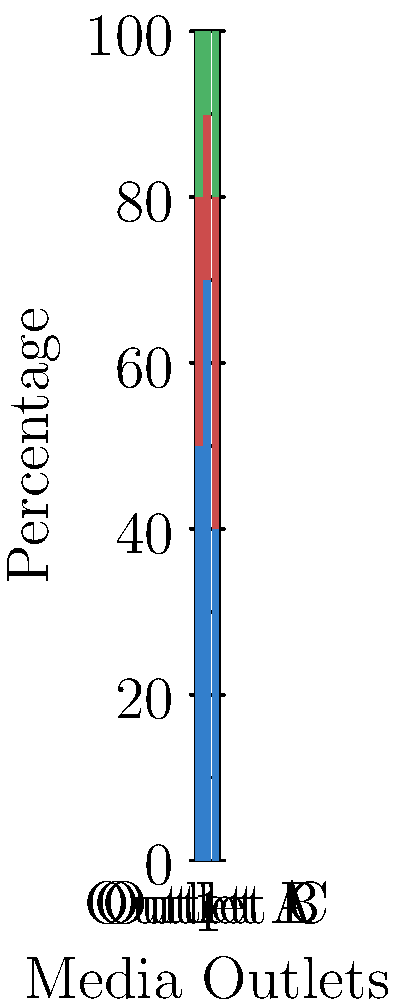As a novelist who values investigative journalism, you're examining the funding sources of different media outlets. Based on the stacked bar chart, which outlet appears to have the most balanced funding structure, potentially allowing for greater editorial independence? To determine which outlet has the most balanced funding structure, we need to analyze the distribution of funding sources for each outlet:

1. Outlet A:
   - Advertising: 50%
   - Subscriptions: 30%
   - Donations: 20%

2. Outlet B:
   - Advertising: 70%
   - Subscriptions: 20%
   - Donations: 10%

3. Outlet C:
   - Advertising: 40%
   - Subscriptions: 40%
   - Donations: 20%

A balanced funding structure would ideally have a more even distribution across different sources, reducing dependence on any single source. This can potentially lead to greater editorial independence, as the outlet is less likely to be influenced by the interests of a dominant funding source.

Analyzing each outlet:

1. Outlet A has a moderate balance, with advertising being the largest source but not overwhelmingly dominant.
2. Outlet B is heavily reliant on advertising, which could potentially compromise editorial independence.
3. Outlet C has the most even distribution, with equal contributions from advertising and subscriptions, and a significant portion from donations.

Outlet C demonstrates the most balanced funding structure among the three, with two equal major sources and a substantial third source. This diversity in funding could potentially allow for greater editorial independence, as the outlet is not overly reliant on any single source.
Answer: Outlet C 